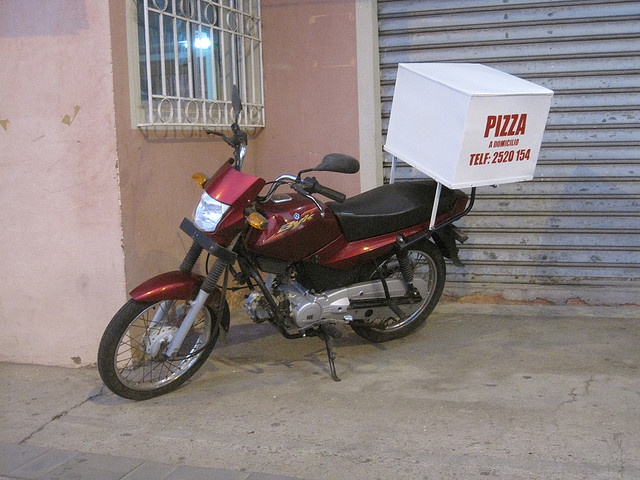Describe the objects in this image and their specific colors. I can see a motorcycle in gray, black, and maroon tones in this image. 